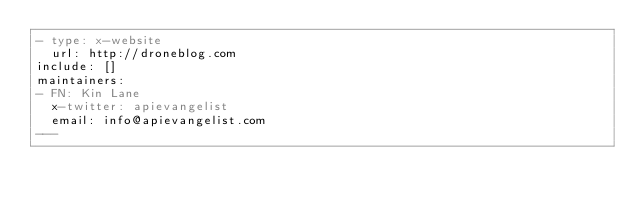Convert code to text. <code><loc_0><loc_0><loc_500><loc_500><_YAML_>- type: x-website
  url: http://droneblog.com
include: []
maintainers:
- FN: Kin Lane
  x-twitter: apievangelist
  email: info@apievangelist.com
---</code> 